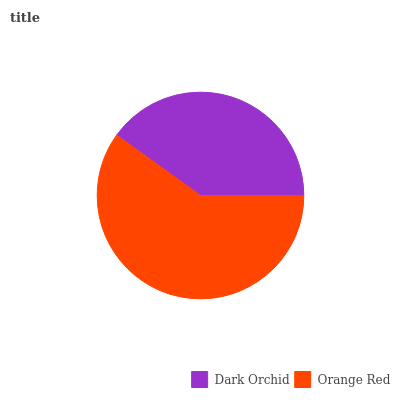Is Dark Orchid the minimum?
Answer yes or no. Yes. Is Orange Red the maximum?
Answer yes or no. Yes. Is Orange Red the minimum?
Answer yes or no. No. Is Orange Red greater than Dark Orchid?
Answer yes or no. Yes. Is Dark Orchid less than Orange Red?
Answer yes or no. Yes. Is Dark Orchid greater than Orange Red?
Answer yes or no. No. Is Orange Red less than Dark Orchid?
Answer yes or no. No. Is Orange Red the high median?
Answer yes or no. Yes. Is Dark Orchid the low median?
Answer yes or no. Yes. Is Dark Orchid the high median?
Answer yes or no. No. Is Orange Red the low median?
Answer yes or no. No. 